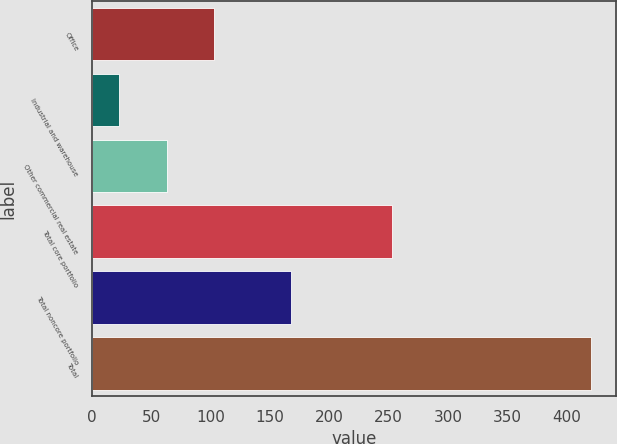<chart> <loc_0><loc_0><loc_500><loc_500><bar_chart><fcel>Office<fcel>Industrial and warehouse<fcel>Other commercial real estate<fcel>Total core portfolio<fcel>Total noncore portfolio<fcel>Total<nl><fcel>102.6<fcel>23<fcel>62.8<fcel>253<fcel>168<fcel>421<nl></chart> 